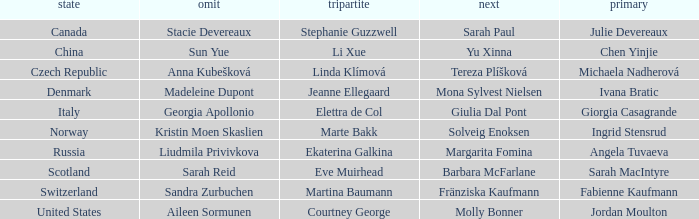What skip has norway as the country? Kristin Moen Skaslien. 